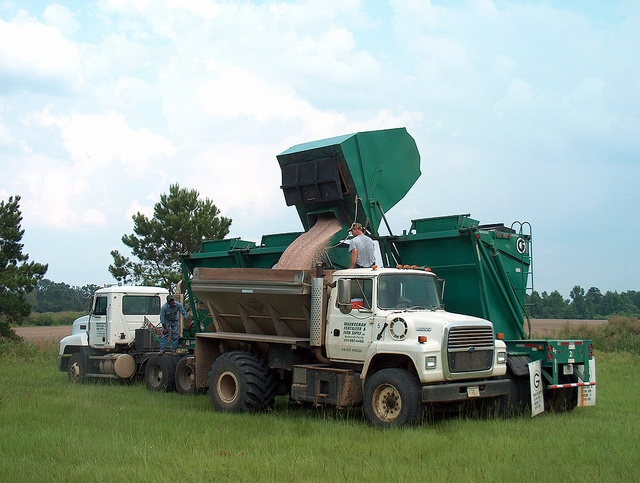Describe the objects in this image and their specific colors. I can see truck in lightblue, black, gray, darkgray, and lightgray tones, truck in lightblue, black, lightgray, gray, and darkgray tones, people in lightblue, black, blue, gray, and darkblue tones, and people in lightblue, darkgray, brown, gray, and lightgray tones in this image. 